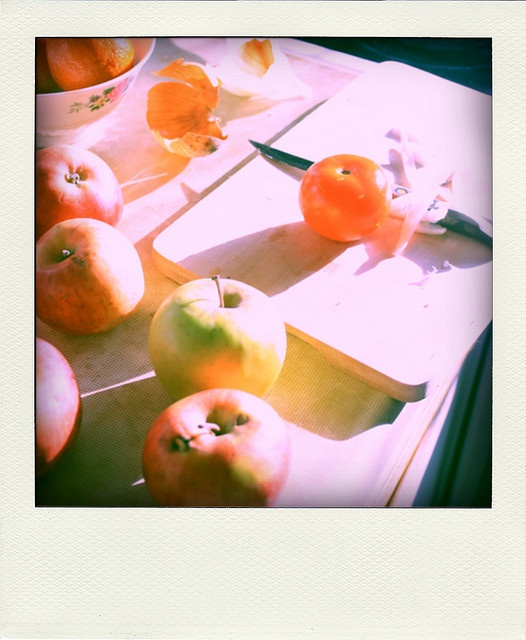Describe the objects in this image and their specific colors. I can see dining table in lightgray, lavender, black, lightpink, and orange tones, apple in lightgray, pink, brown, and maroon tones, apple in lightgray, maroon, pink, lightpink, and brown tones, apple in lightgray, lavender, olive, orange, and tan tones, and bowl in lightgray, lightpink, brown, red, and maroon tones in this image. 